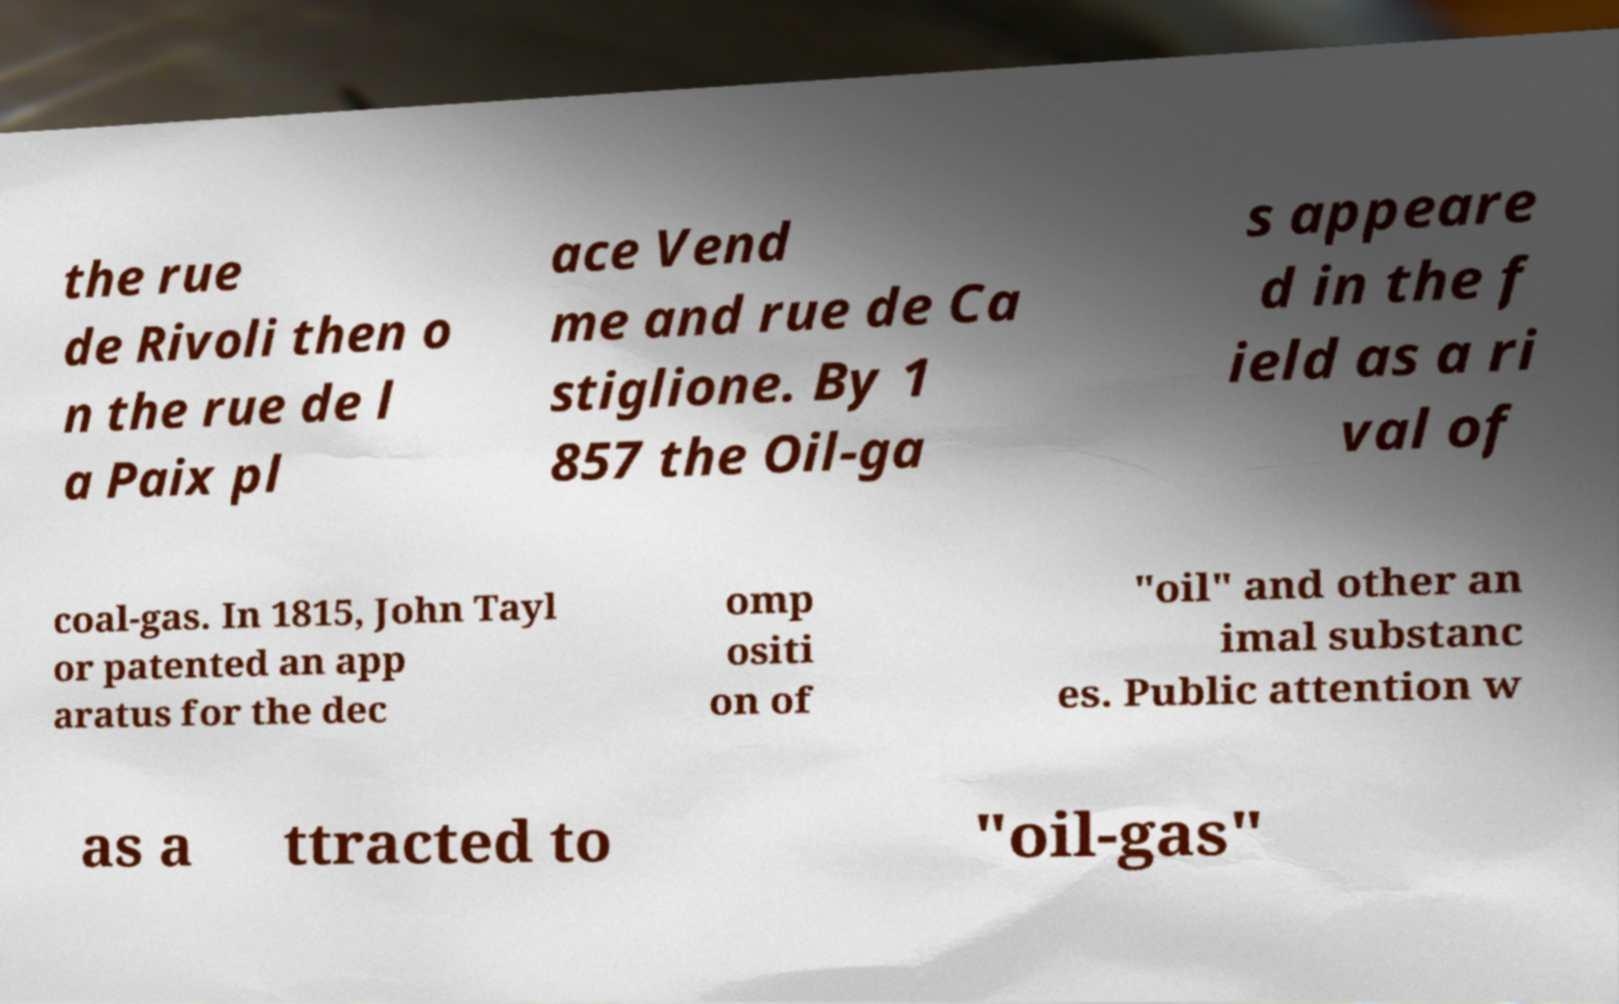Please identify and transcribe the text found in this image. the rue de Rivoli then o n the rue de l a Paix pl ace Vend me and rue de Ca stiglione. By 1 857 the Oil-ga s appeare d in the f ield as a ri val of coal-gas. In 1815, John Tayl or patented an app aratus for the dec omp ositi on of "oil" and other an imal substanc es. Public attention w as a ttracted to "oil-gas" 